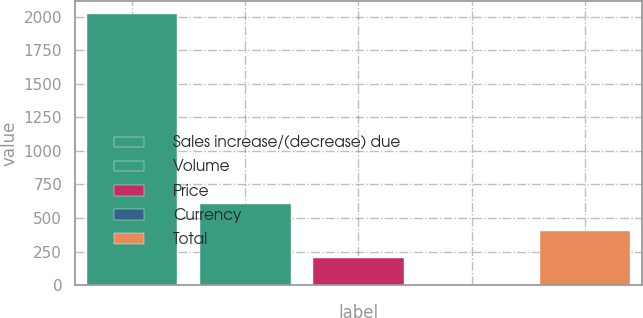Convert chart to OTSL. <chart><loc_0><loc_0><loc_500><loc_500><bar_chart><fcel>Sales increase/(decrease) due<fcel>Volume<fcel>Price<fcel>Currency<fcel>Total<nl><fcel>2017<fcel>605.31<fcel>201.97<fcel>0.3<fcel>403.64<nl></chart> 